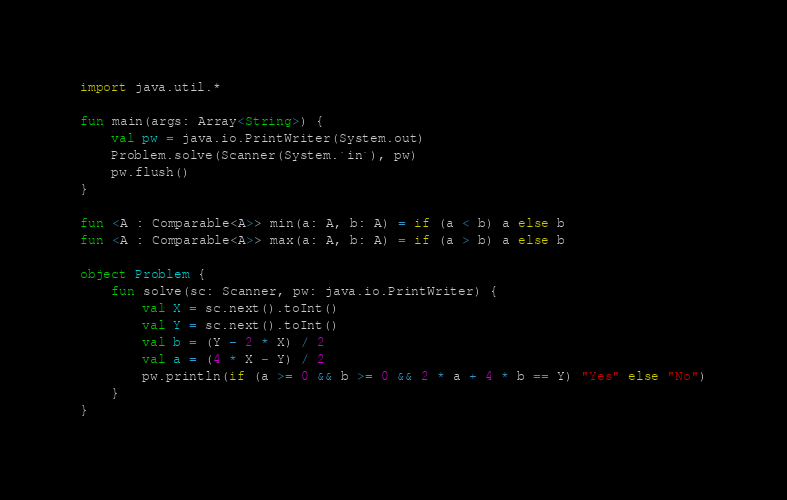<code> <loc_0><loc_0><loc_500><loc_500><_Kotlin_>import java.util.*

fun main(args: Array<String>) {
    val pw = java.io.PrintWriter(System.out)
    Problem.solve(Scanner(System.`in`), pw)
    pw.flush()
}

fun <A : Comparable<A>> min(a: A, b: A) = if (a < b) a else b
fun <A : Comparable<A>> max(a: A, b: A) = if (a > b) a else b

object Problem {
    fun solve(sc: Scanner, pw: java.io.PrintWriter) {
        val X = sc.next().toInt()
        val Y = sc.next().toInt()
        val b = (Y - 2 * X) / 2
        val a = (4 * X - Y) / 2
        pw.println(if (a >= 0 && b >= 0 && 2 * a + 4 * b == Y) "Yes" else "No")
    }
}
</code> 